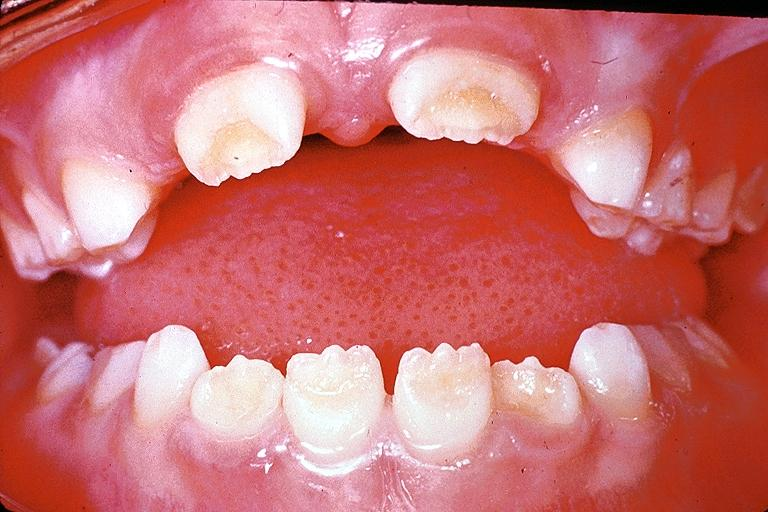what is present?
Answer the question using a single word or phrase. Oral 